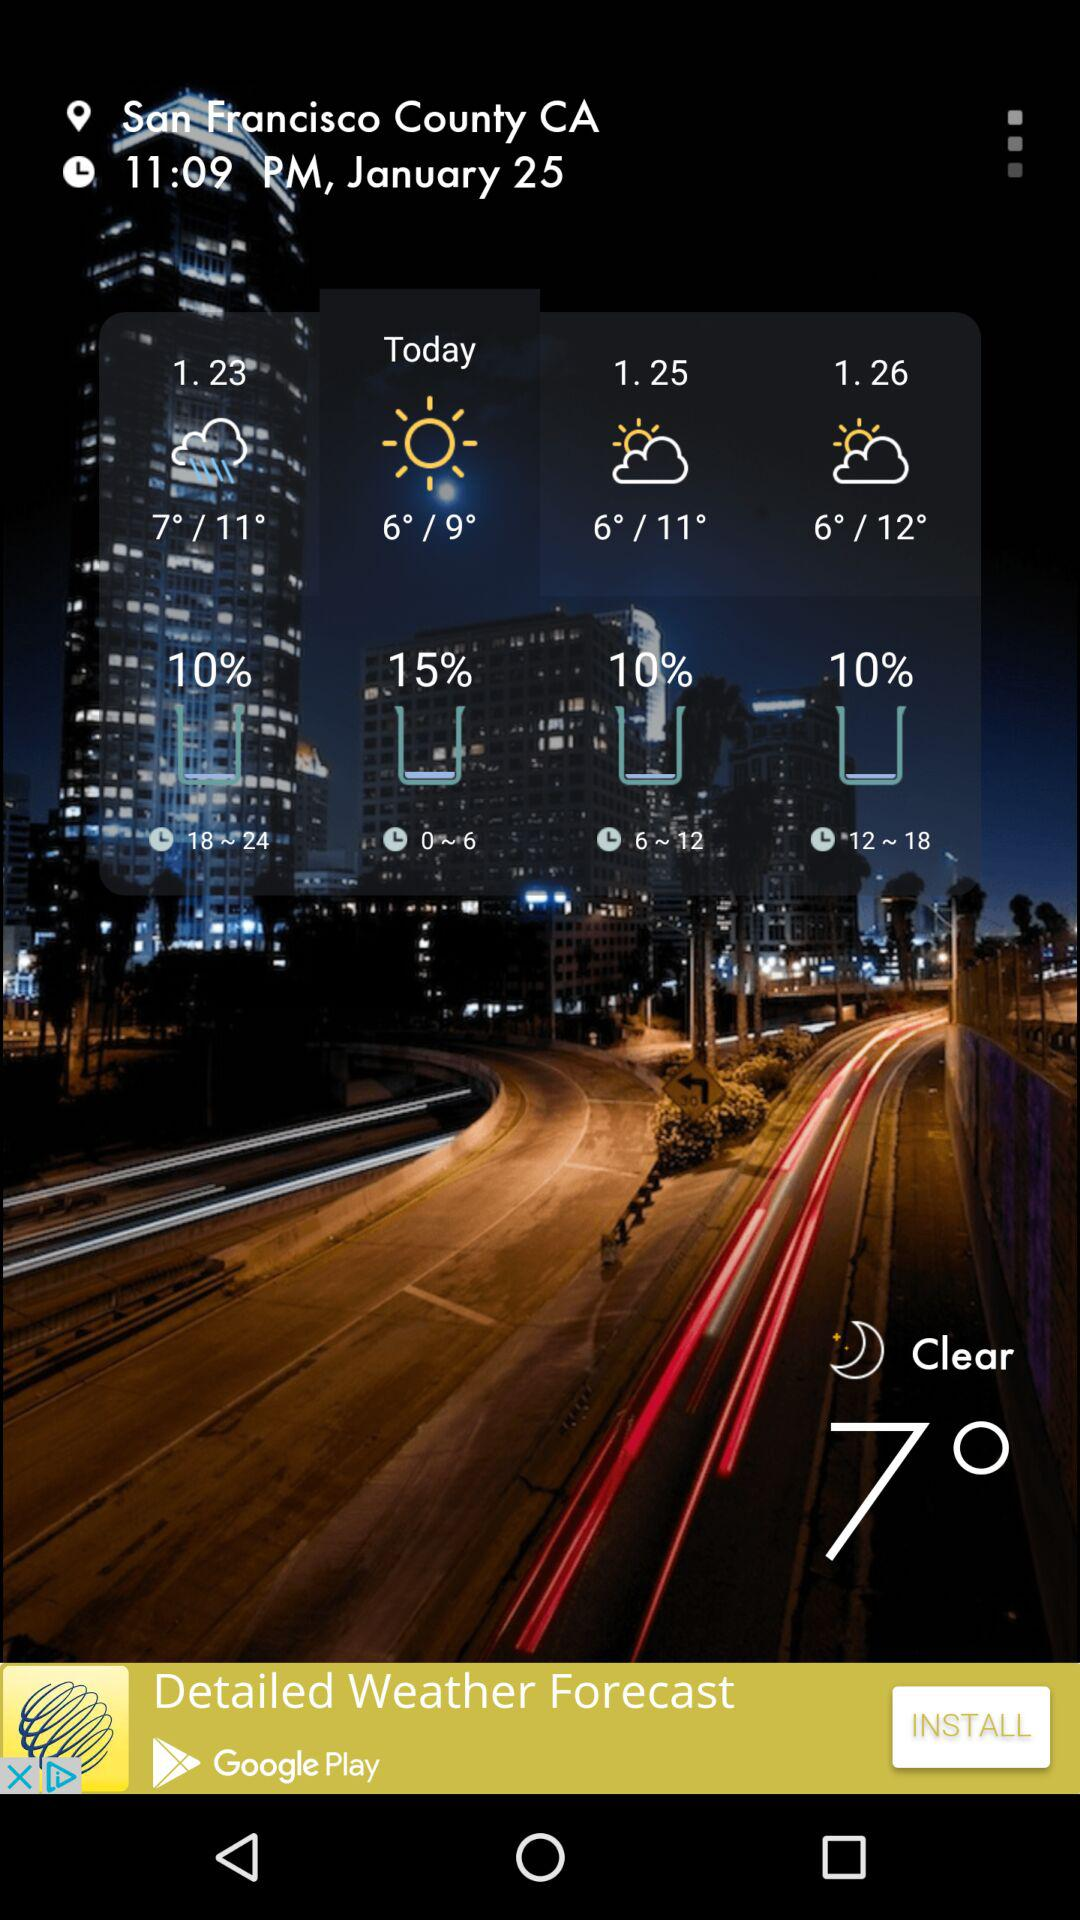What is the current temperature? The current temperature is 7°. 